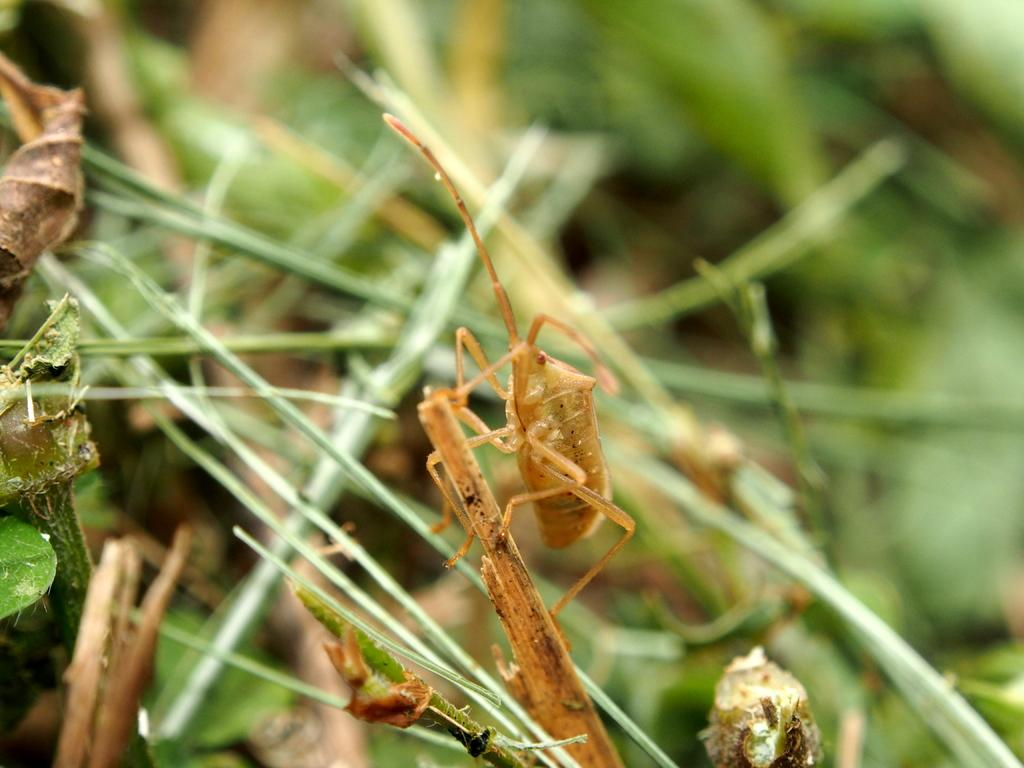What object can be seen in the image? There is a stick in the image. What is on the stick? There is a brown color insect on the stick. What can be seen in the background of the image? There are stems visible in the background of the image. How would you describe the background of the image? The background is blurred. How does the effect of the insect's brain influence the movement of the ants in the image? There are no ants present in the image, and therefore no influence on their movement can be observed. 